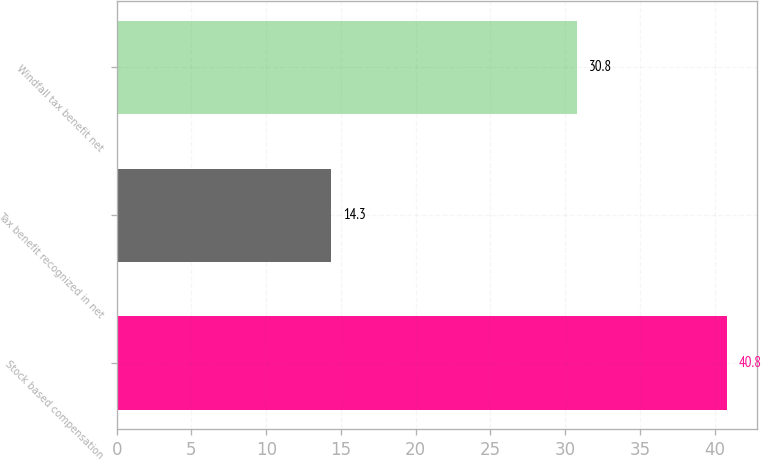Convert chart to OTSL. <chart><loc_0><loc_0><loc_500><loc_500><bar_chart><fcel>Stock based compensation<fcel>Tax benefit recognized in net<fcel>Windfall tax benefit net<nl><fcel>40.8<fcel>14.3<fcel>30.8<nl></chart> 